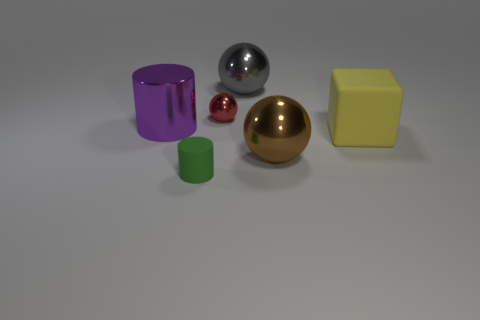Does the cylinder that is on the right side of the large metal cylinder have the same size as the brown sphere to the right of the large purple thing?
Give a very brief answer. No. What number of big purple objects have the same material as the brown object?
Offer a terse response. 1. Is there a large object in front of the small object to the right of the object that is in front of the brown thing?
Give a very brief answer. Yes. What number of cylinders are red matte objects or small red metal things?
Your answer should be compact. 0. There is a large gray metallic thing; is it the same shape as the metal object in front of the shiny cylinder?
Provide a succinct answer. Yes. Are there fewer shiny objects that are behind the tiny red sphere than big shiny cylinders?
Your response must be concise. No. Are there any purple metal objects behind the yellow cube?
Keep it short and to the point. Yes. Is there another thing that has the same shape as the green matte object?
Make the answer very short. Yes. There is a yellow rubber object that is the same size as the brown ball; what is its shape?
Provide a short and direct response. Cube. What number of things are big metal things that are behind the purple metal cylinder or red things?
Provide a short and direct response. 2. 